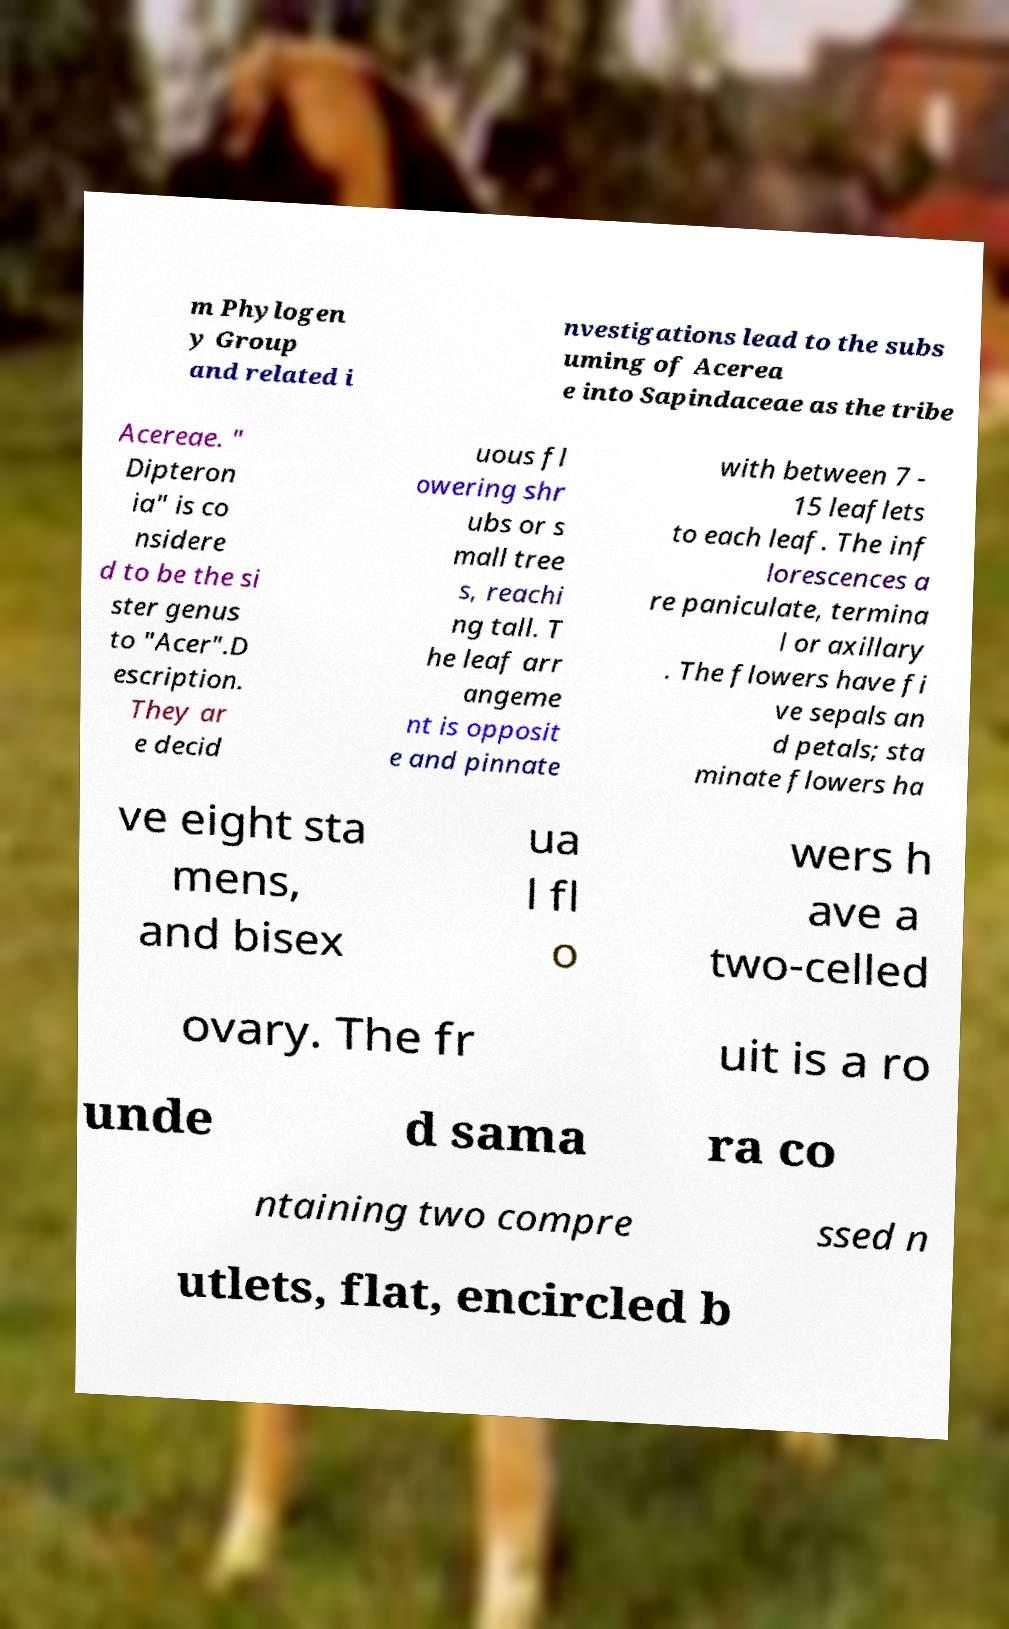Please read and relay the text visible in this image. What does it say? m Phylogen y Group and related i nvestigations lead to the subs uming of Acerea e into Sapindaceae as the tribe Acereae. " Dipteron ia" is co nsidere d to be the si ster genus to "Acer".D escription. They ar e decid uous fl owering shr ubs or s mall tree s, reachi ng tall. T he leaf arr angeme nt is opposit e and pinnate with between 7 - 15 leaflets to each leaf. The inf lorescences a re paniculate, termina l or axillary . The flowers have fi ve sepals an d petals; sta minate flowers ha ve eight sta mens, and bisex ua l fl o wers h ave a two-celled ovary. The fr uit is a ro unde d sama ra co ntaining two compre ssed n utlets, flat, encircled b 